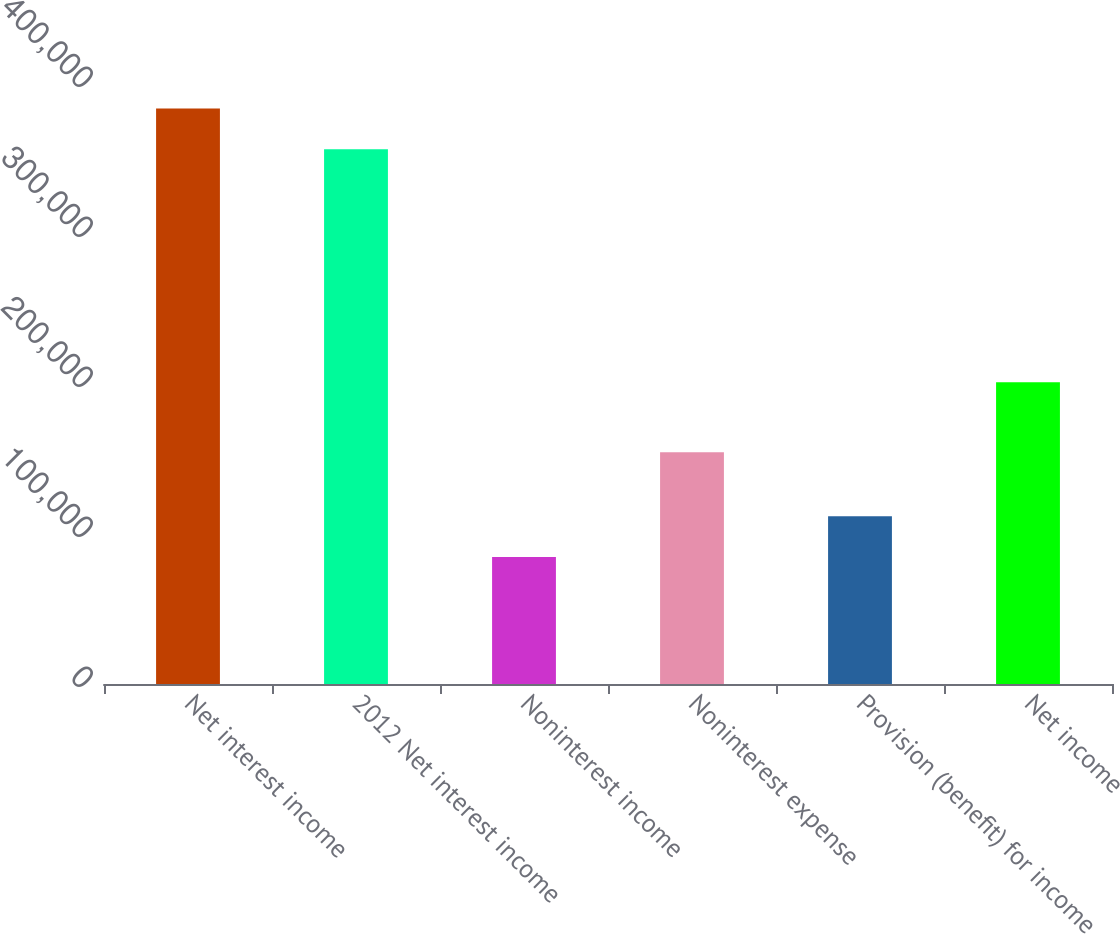<chart> <loc_0><loc_0><loc_500><loc_500><bar_chart><fcel>Net interest income<fcel>2012 Net interest income<fcel>Noninterest income<fcel>Noninterest expense<fcel>Provision (benefit) for income<fcel>Net income<nl><fcel>383629<fcel>356442<fcel>84619<fcel>154480<fcel>111806<fcel>201203<nl></chart> 